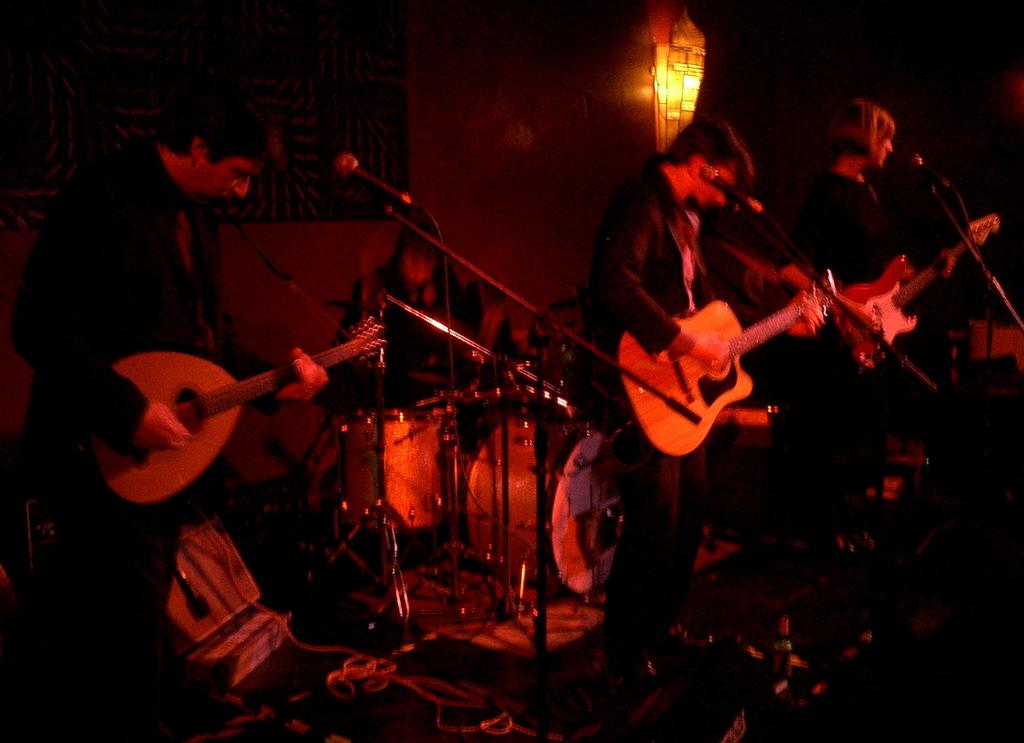How many people are in the image? There are three persons in the image. What are the three persons doing in the image? They are playing a guitar. What object is in front of the three persons? They are in front of a microphone. What is the position of one person in the image? One person is sitting on a chair. What can be seen at the top of the image? There is a light visible at the top of the image. What type of prose is being recited by the person sitting on the chair? There is no indication in the image that any prose is being recited; the focus is on the three persons playing a guitar. What color is the shirt of the person standing next to the microphone? The image does not provide information about the color of any person's shirt, as it focuses on the activity of playing a guitar and the presence of a microphone. 